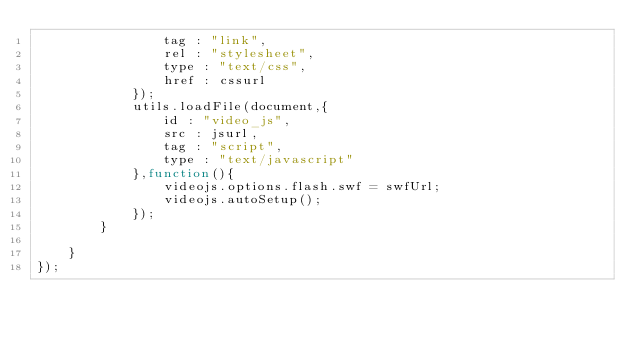Convert code to text. <code><loc_0><loc_0><loc_500><loc_500><_JavaScript_>                tag : "link",
                rel : "stylesheet",
                type : "text/css",
                href : cssurl
            });
            utils.loadFile(document,{
                id : "video_js",
                src : jsurl,
                tag : "script",
                type : "text/javascript"
            },function(){
                videojs.options.flash.swf = swfUrl;
                videojs.autoSetup();
            });
        }

    }
});</code> 